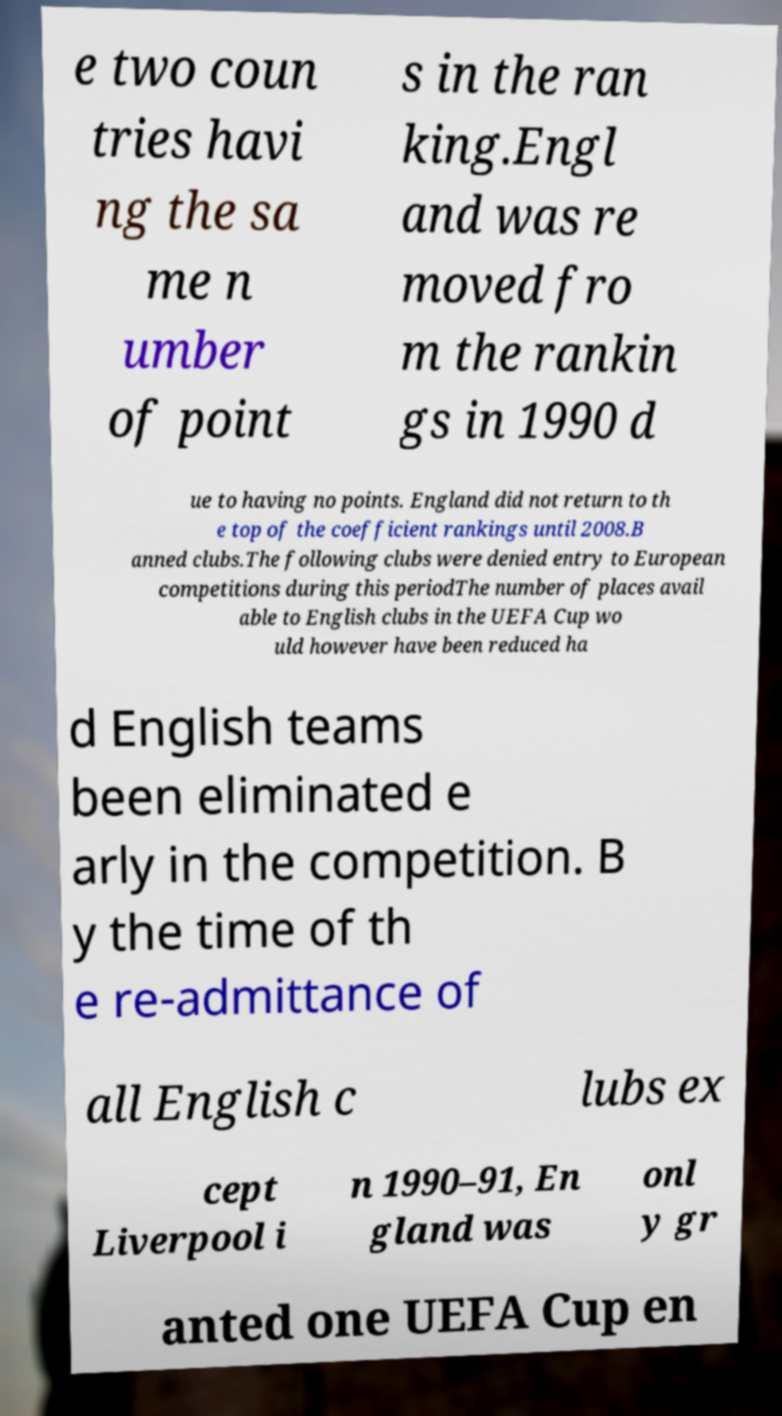Please read and relay the text visible in this image. What does it say? e two coun tries havi ng the sa me n umber of point s in the ran king.Engl and was re moved fro m the rankin gs in 1990 d ue to having no points. England did not return to th e top of the coefficient rankings until 2008.B anned clubs.The following clubs were denied entry to European competitions during this periodThe number of places avail able to English clubs in the UEFA Cup wo uld however have been reduced ha d English teams been eliminated e arly in the competition. B y the time of th e re-admittance of all English c lubs ex cept Liverpool i n 1990–91, En gland was onl y gr anted one UEFA Cup en 